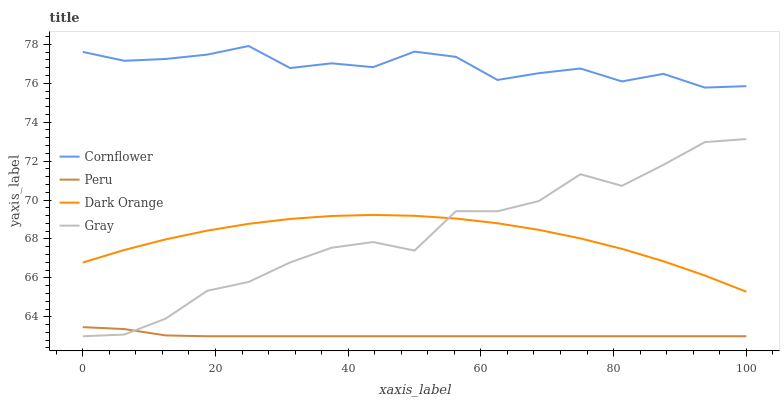Does Peru have the minimum area under the curve?
Answer yes or no. Yes. Does Cornflower have the maximum area under the curve?
Answer yes or no. Yes. Does Gray have the minimum area under the curve?
Answer yes or no. No. Does Gray have the maximum area under the curve?
Answer yes or no. No. Is Peru the smoothest?
Answer yes or no. Yes. Is Gray the roughest?
Answer yes or no. Yes. Is Gray the smoothest?
Answer yes or no. No. Is Peru the roughest?
Answer yes or no. No. Does Gray have the lowest value?
Answer yes or no. Yes. Does Dark Orange have the lowest value?
Answer yes or no. No. Does Cornflower have the highest value?
Answer yes or no. Yes. Does Gray have the highest value?
Answer yes or no. No. Is Dark Orange less than Cornflower?
Answer yes or no. Yes. Is Cornflower greater than Dark Orange?
Answer yes or no. Yes. Does Peru intersect Gray?
Answer yes or no. Yes. Is Peru less than Gray?
Answer yes or no. No. Is Peru greater than Gray?
Answer yes or no. No. Does Dark Orange intersect Cornflower?
Answer yes or no. No. 